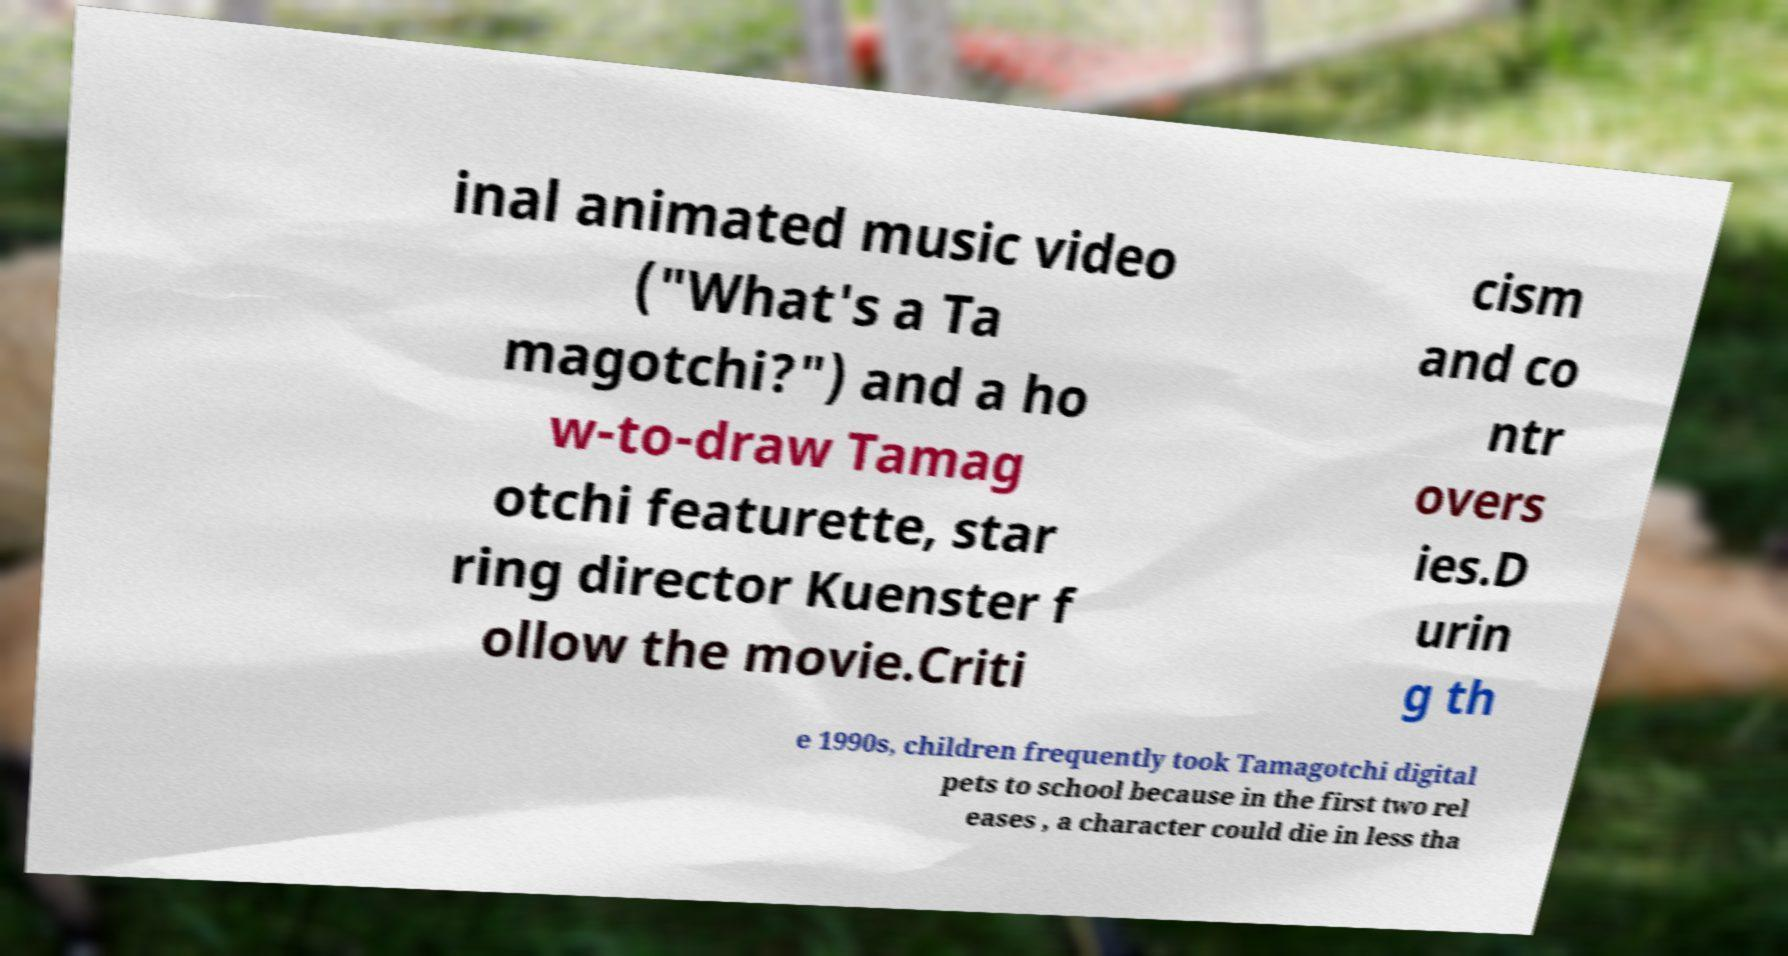Can you read and provide the text displayed in the image?This photo seems to have some interesting text. Can you extract and type it out for me? inal animated music video ("What's a Ta magotchi?") and a ho w-to-draw Tamag otchi featurette, star ring director Kuenster f ollow the movie.Criti cism and co ntr overs ies.D urin g th e 1990s, children frequently took Tamagotchi digital pets to school because in the first two rel eases , a character could die in less tha 